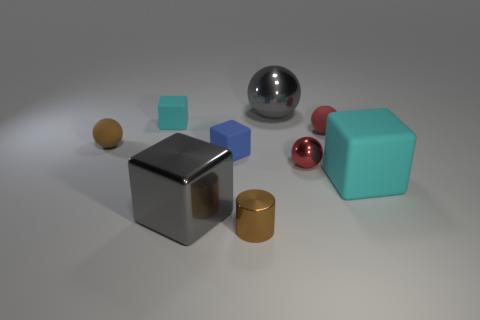Can you tell me what shapes are present in the image and in what colors? Certainly! The image contains a variety of shapes: there are cubes in blue and larger ones in teal, a large silver sphere, a small red sphere, a gold cylinder, and a small ochre sphere as well. Which is the largest object in the image? The largest object appears to be the teal cube, as it has a more substantial size compared to the other shapes in the image. 